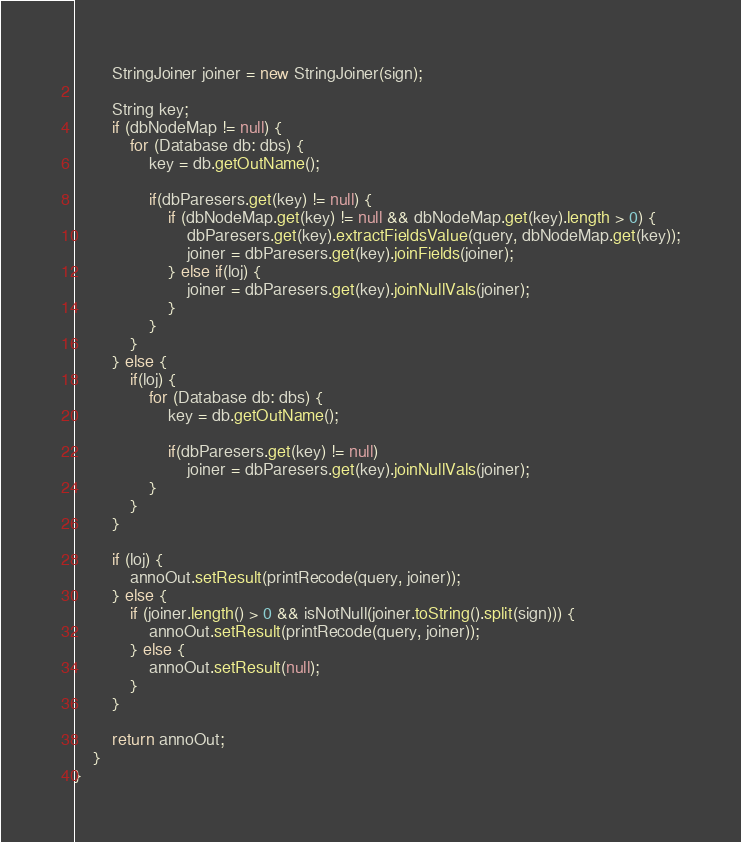Convert code to text. <code><loc_0><loc_0><loc_500><loc_500><_Java_>		StringJoiner joiner = new StringJoiner(sign);

		String key;
		if (dbNodeMap != null) {
			for (Database db: dbs) {
				key = db.getOutName();

				if(dbParesers.get(key) != null) {
					if (dbNodeMap.get(key) != null && dbNodeMap.get(key).length > 0) {
						dbParesers.get(key).extractFieldsValue(query, dbNodeMap.get(key));
						joiner = dbParesers.get(key).joinFields(joiner);
					} else if(loj) {
						joiner = dbParesers.get(key).joinNullVals(joiner);
					}
				}
			}
		} else {
			if(loj) {
				for (Database db: dbs) {
					key = db.getOutName();

					if(dbParesers.get(key) != null)
						joiner = dbParesers.get(key).joinNullVals(joiner);
				}
			}
		}

		if (loj) {
			annoOut.setResult(printRecode(query, joiner));
		} else {
			if (joiner.length() > 0 && isNotNull(joiner.toString().split(sign))) {
				annoOut.setResult(printRecode(query, joiner));
			} else {
				annoOut.setResult(null);
			}
		}

		return annoOut;
	}
}
</code> 